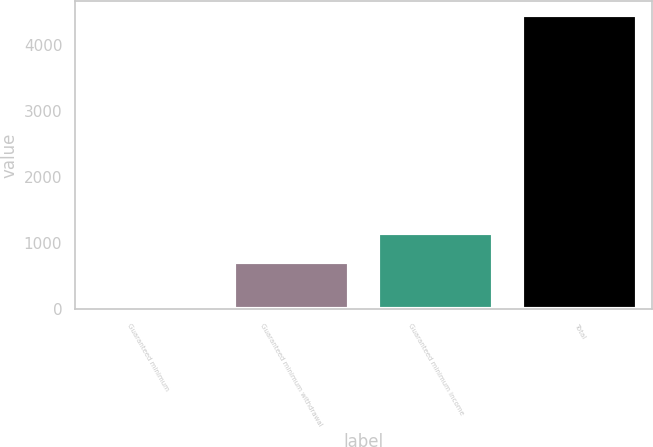Convert chart. <chart><loc_0><loc_0><loc_500><loc_500><bar_chart><fcel>Guaranteed minimum<fcel>Guaranteed minimum withdrawal<fcel>Guaranteed minimum income<fcel>Total<nl><fcel>52<fcel>710<fcel>1149.2<fcel>4444<nl></chart> 